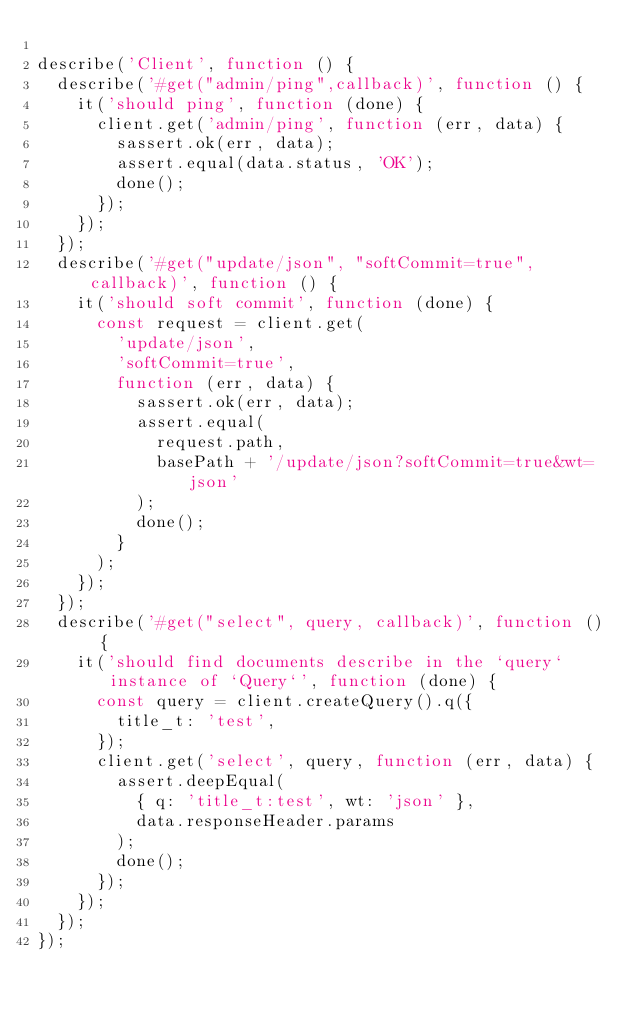Convert code to text. <code><loc_0><loc_0><loc_500><loc_500><_JavaScript_>
describe('Client', function () {
  describe('#get("admin/ping",callback)', function () {
    it('should ping', function (done) {
      client.get('admin/ping', function (err, data) {
        sassert.ok(err, data);
        assert.equal(data.status, 'OK');
        done();
      });
    });
  });
  describe('#get("update/json", "softCommit=true", callback)', function () {
    it('should soft commit', function (done) {
      const request = client.get(
        'update/json',
        'softCommit=true',
        function (err, data) {
          sassert.ok(err, data);
          assert.equal(
            request.path,
            basePath + '/update/json?softCommit=true&wt=json'
          );
          done();
        }
      );
    });
  });
  describe('#get("select", query, callback)', function () {
    it('should find documents describe in the `query` instance of `Query`', function (done) {
      const query = client.createQuery().q({
        title_t: 'test',
      });
      client.get('select', query, function (err, data) {
        assert.deepEqual(
          { q: 'title_t:test', wt: 'json' },
          data.responseHeader.params
        );
        done();
      });
    });
  });
});
</code> 